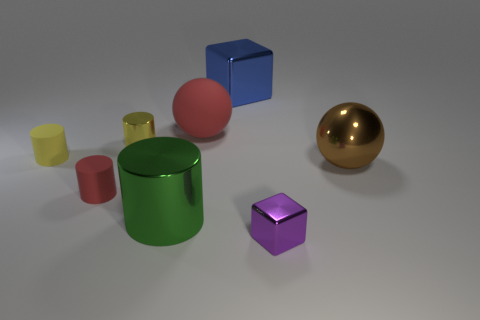Subtract 1 cylinders. How many cylinders are left? 3 Add 2 large purple blocks. How many objects exist? 10 Subtract all spheres. How many objects are left? 6 Subtract 1 green cylinders. How many objects are left? 7 Subtract all small red rubber cylinders. Subtract all brown metallic things. How many objects are left? 6 Add 5 purple things. How many purple things are left? 6 Add 3 big blue things. How many big blue things exist? 4 